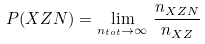<formula> <loc_0><loc_0><loc_500><loc_500>P ( X Z N ) = \lim _ { n _ { t o t } \to \infty } \, \frac { n _ { X Z N } } { n _ { X Z } }</formula> 